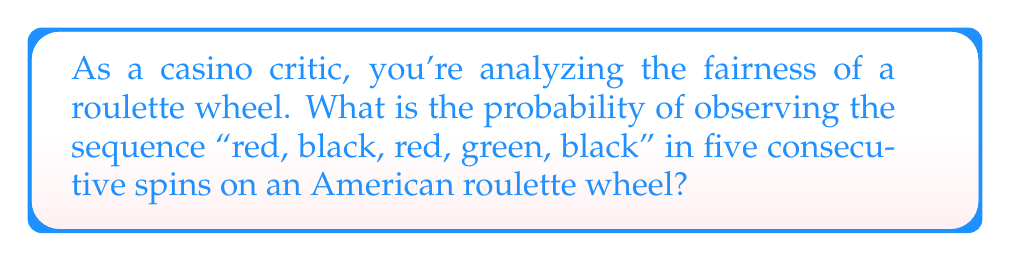Can you answer this question? Let's approach this step-by-step:

1) First, let's recall the composition of an American roulette wheel:
   - 18 red numbers
   - 18 black numbers
   - 2 green numbers (0 and 00)
   - Total of 38 pockets

2) Now, let's calculate the probability of each outcome:
   - P(red) = $\frac{18}{38}$
   - P(black) = $\frac{18}{38}$
   - P(green) = $\frac{2}{38}$

3) For independent events, we multiply the individual probabilities:

   P(red, black, red, green, black) = P(red) × P(black) × P(red) × P(green) × P(black)

4) Substituting the values:

   $$P(\text{sequence}) = \frac{18}{38} \times \frac{18}{38} \times \frac{18}{38} \times \frac{2}{38} \times \frac{18}{38}$$

5) Simplifying:

   $$P(\text{sequence}) = \frac{18^4 \times 2}{38^5} = \frac{104,976}{79,235,168}$$

6) This can be further reduced to:

   $$P(\text{sequence}) = \frac{13,122}{9,904,396} \approx 0.0013249$$
Answer: $\frac{13,122}{9,904,396}$ or approximately 0.0013249 